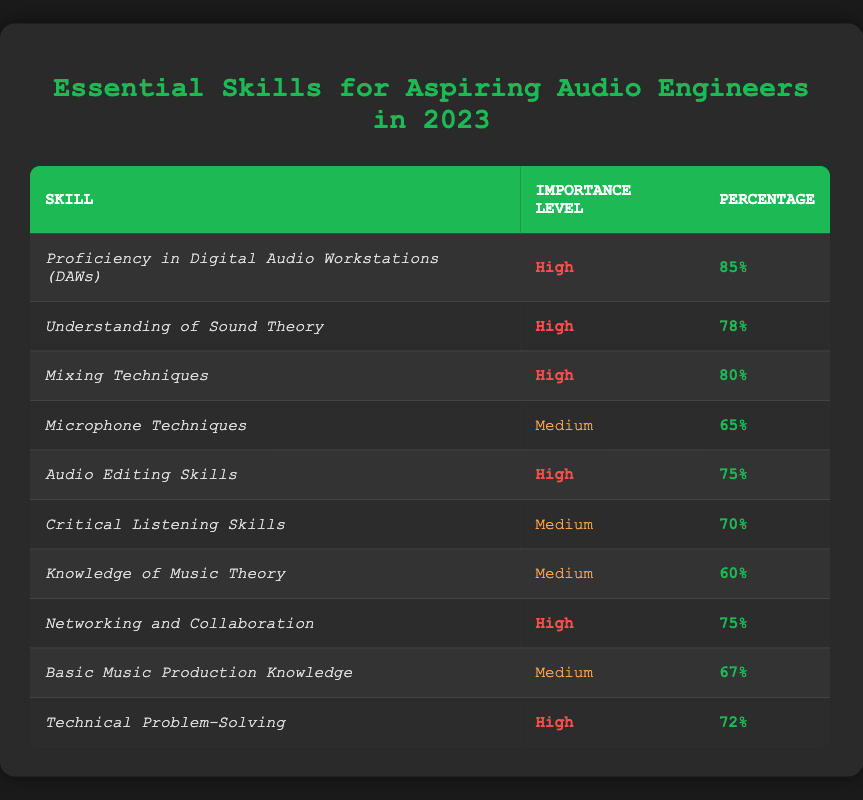What skill has the highest percentage regarding importance for aspiring audio engineers? The highest percentage listed in the table is 85%, which corresponds to "Proficiency in Digital Audio Workstations (DAWs)." This can be found by scanning through the "Percentage" column for the highest value.
Answer: Proficiency in Digital Audio Workstations (DAWs) Which skill has a medium importance level with a percentage of 60? In the "Importance Level" column, the skill with a medium importance level and a percentage of 60 is "Knowledge of Music Theory." This is directly found by looking for the specific percentage under the medium category.
Answer: Knowledge of Music Theory What is the average percentage of skills listed as high importance? The skills rated as high importance are: 85%, 78%, 80%, 75%, 75%, and 72%. First, we sum these percentages: 85 + 78 + 80 + 75 + 75 + 72 = 465. Since there are 6 skills, we divide this total by 6, giving us an average of 465/6 = 77.5.
Answer: 77.5 Is "Critical Listening Skills" considered a high importance skill according to the survey results? In the "Importance Level" column, "Critical Listening Skills" is categorized as medium, thus it is not considered a high importance skill according to the survey results.
Answer: No How many skills have a percentage above 70? The skills with percentages above 70 are: "Proficiency in Digital Audio Workstations (DAWs)" (85%), "Understanding of Sound Theory" (78%), "Mixing Techniques" (80%), "Audio Editing Skills" (75%), "Networking and Collaboration" (75%), and "Technical Problem-Solving" (72%). Counting these, we find there are 6 skills with percentages above 70.
Answer: 6 